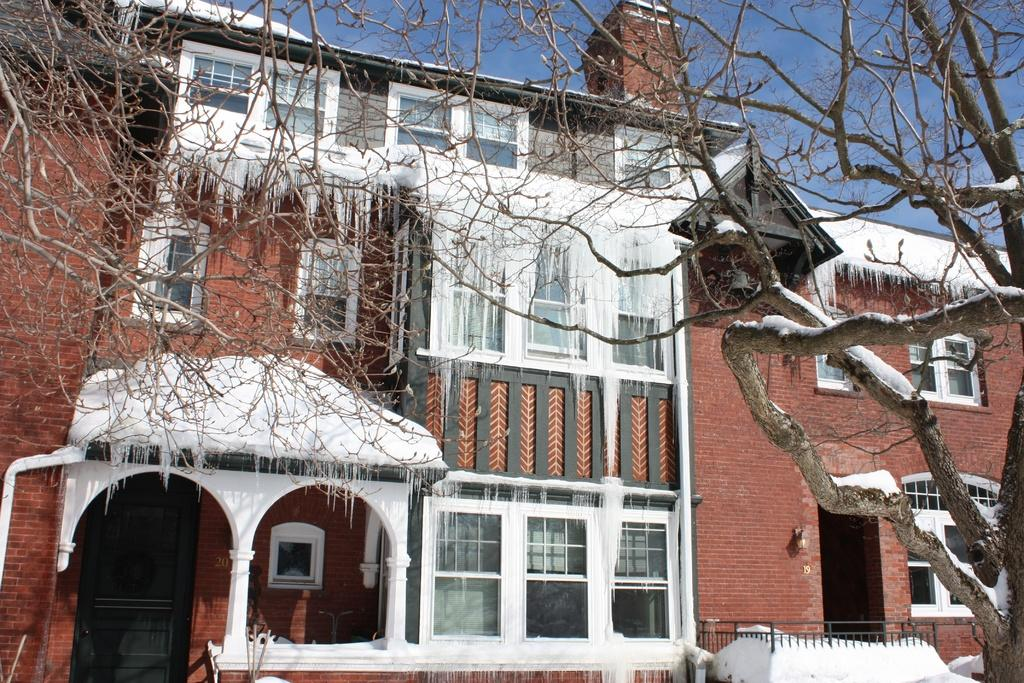What type of structure is present in the image? There is a building in the image. What can be seen on the right side of the image? There is a tree on the right side of the image. What is located at the bottom of the image? There is a railing at the bottom of the image. What is the weather like in the image? Snow is visible in the image, indicating a cold or wintry weather. What is visible in the background of the image? There is sky visible in the background of the image. What type of bulb is used to light up the book on the table in the image? There is no book or table present in the image; it only features a building, a tree, a railing, snow, and sky. How much rice is visible in the image? There is no rice present in the image. 